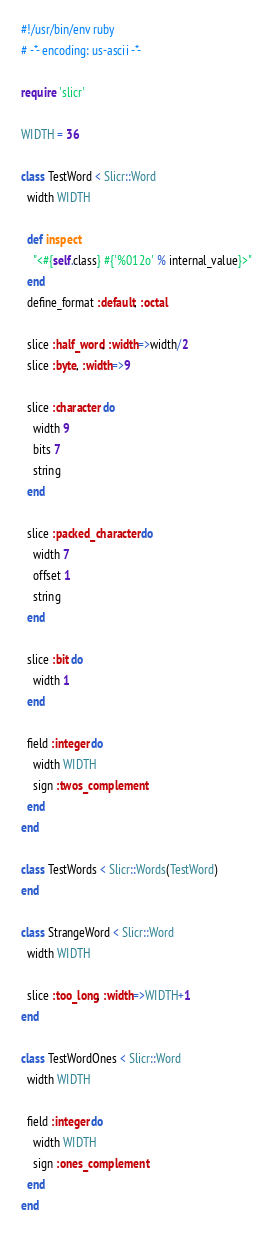Convert code to text. <code><loc_0><loc_0><loc_500><loc_500><_Ruby_>#!/usr/bin/env ruby
# -*- encoding: us-ascii -*-

require 'slicr'

WIDTH = 36

class TestWord < Slicr::Word
  width WIDTH
  
  def inspect
    "<#{self.class} #{'%012o' % internal_value}>"
  end
  define_format :default, :octal
  
  slice :half_word, :width=>width/2
  slice :byte, :width=>9
  
  slice :character do
    width 9
    bits 7
    string
  end
  
  slice :packed_character do
    width 7
    offset 1
    string
  end
  
  slice :bit do
    width 1
  end

  field :integer do
    width WIDTH
    sign :twos_complement
  end
end

class TestWords < Slicr::Words(TestWord)
end

class StrangeWord < Slicr::Word
  width WIDTH
  
  slice :too_long, :width=>WIDTH+1
end

class TestWordOnes < Slicr::Word
  width WIDTH
  
  field :integer do
    width WIDTH
    sign :ones_complement
  end
end</code> 